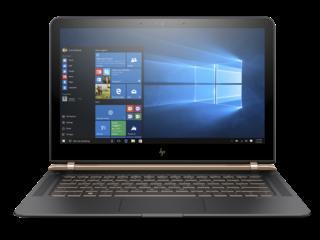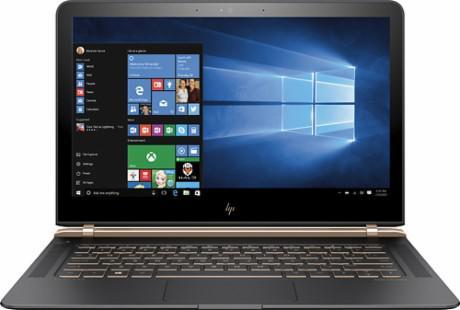The first image is the image on the left, the second image is the image on the right. For the images displayed, is the sentence "Apps are shown on exactly one of the laptops." factually correct? Answer yes or no. No. The first image is the image on the left, the second image is the image on the right. Evaluate the accuracy of this statement regarding the images: "Each image shows one opened laptop displayed turned at an angle.". Is it true? Answer yes or no. No. 